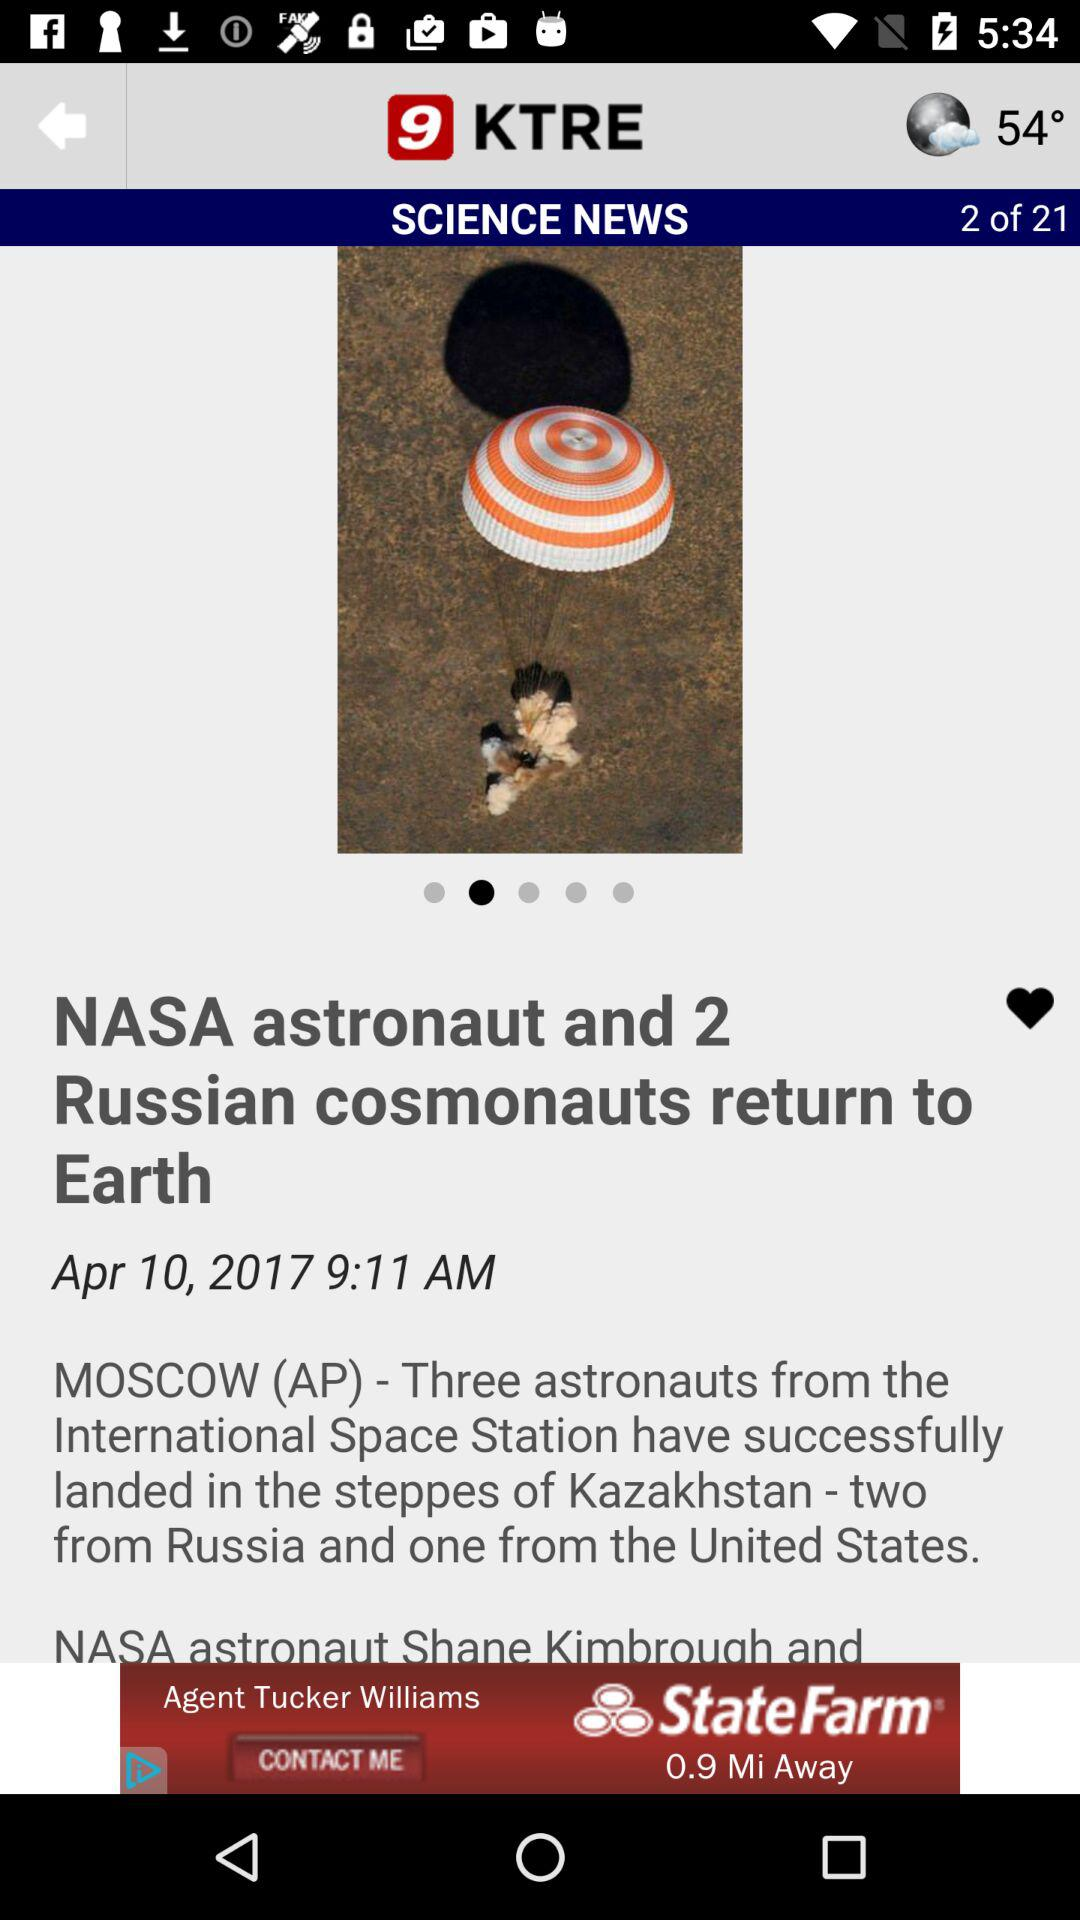What is the time and date? The time is 9:11 AM and the date is April 10, 2017. 